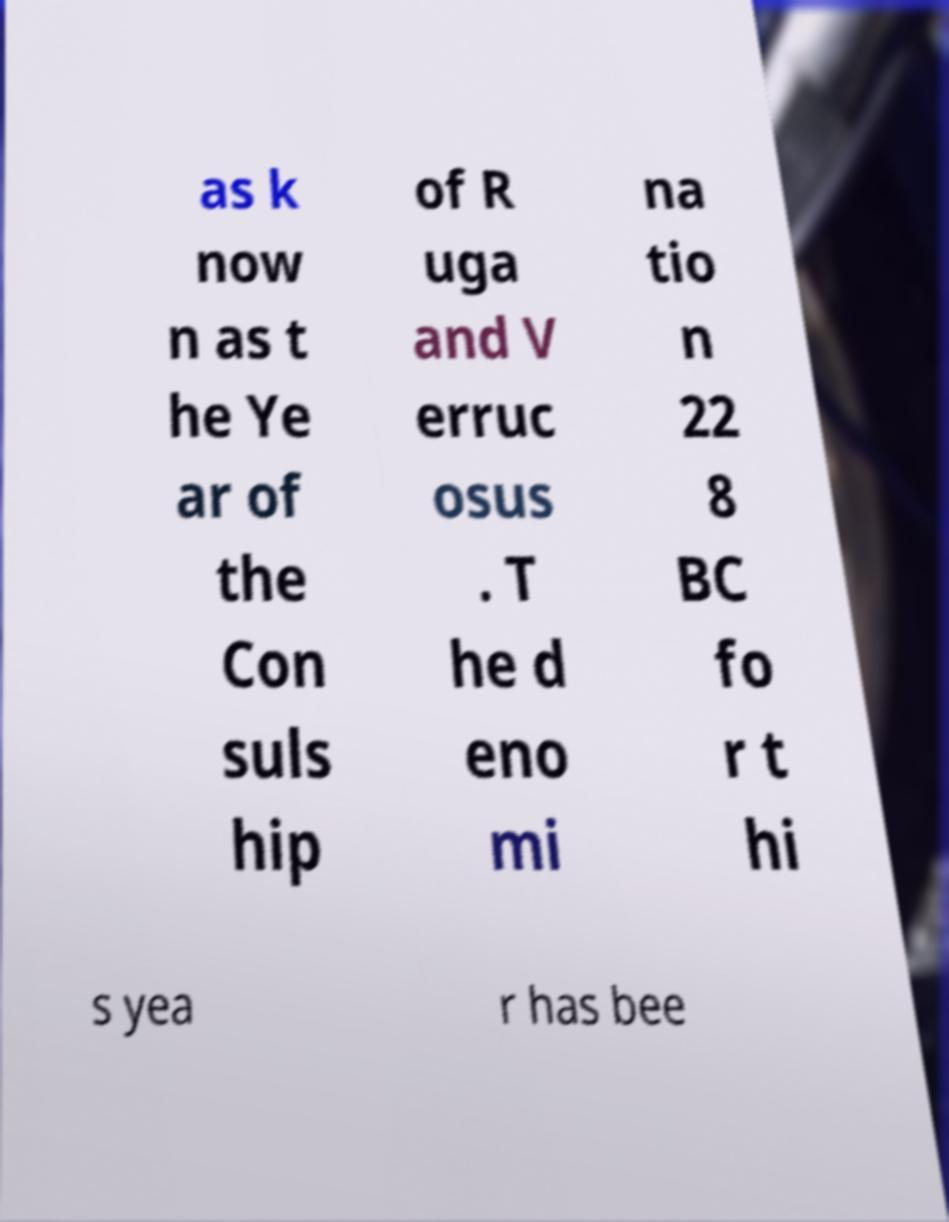Could you extract and type out the text from this image? as k now n as t he Ye ar of the Con suls hip of R uga and V erruc osus . T he d eno mi na tio n 22 8 BC fo r t hi s yea r has bee 